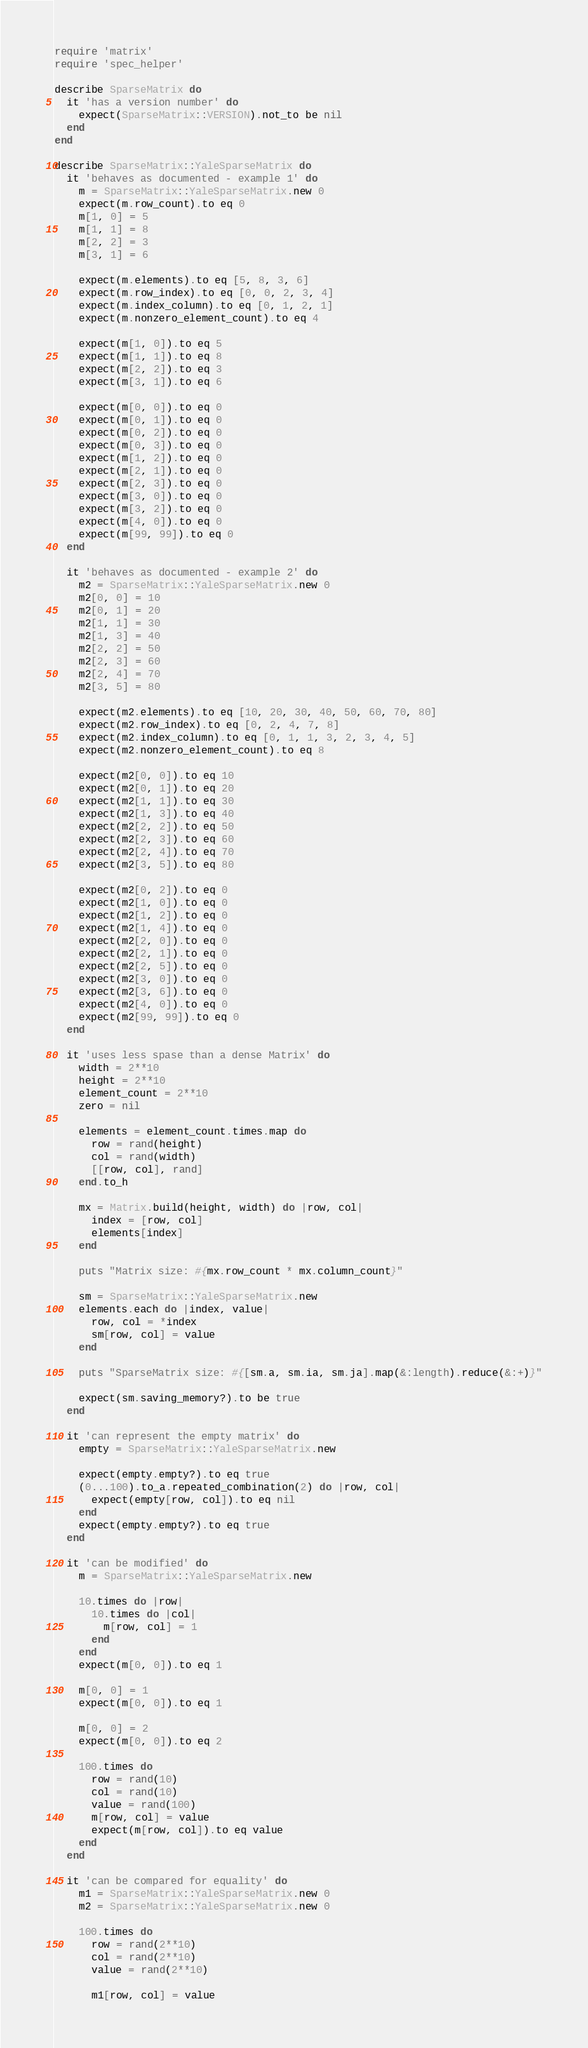Convert code to text. <code><loc_0><loc_0><loc_500><loc_500><_Ruby_>require 'matrix'
require 'spec_helper'

describe SparseMatrix do
  it 'has a version number' do
    expect(SparseMatrix::VERSION).not_to be nil
  end
end

describe SparseMatrix::YaleSparseMatrix do
  it 'behaves as documented - example 1' do
    m = SparseMatrix::YaleSparseMatrix.new 0
    expect(m.row_count).to eq 0
    m[1, 0] = 5
    m[1, 1] = 8
    m[2, 2] = 3
    m[3, 1] = 6

    expect(m.elements).to eq [5, 8, 3, 6]
    expect(m.row_index).to eq [0, 0, 2, 3, 4]
    expect(m.index_column).to eq [0, 1, 2, 1]
    expect(m.nonzero_element_count).to eq 4

    expect(m[1, 0]).to eq 5
    expect(m[1, 1]).to eq 8
    expect(m[2, 2]).to eq 3
    expect(m[3, 1]).to eq 6

    expect(m[0, 0]).to eq 0
    expect(m[0, 1]).to eq 0
    expect(m[0, 2]).to eq 0
    expect(m[0, 3]).to eq 0
    expect(m[1, 2]).to eq 0
    expect(m[2, 1]).to eq 0
    expect(m[2, 3]).to eq 0
    expect(m[3, 0]).to eq 0
    expect(m[3, 2]).to eq 0
    expect(m[4, 0]).to eq 0
    expect(m[99, 99]).to eq 0
  end

  it 'behaves as documented - example 2' do
    m2 = SparseMatrix::YaleSparseMatrix.new 0
    m2[0, 0] = 10
    m2[0, 1] = 20
    m2[1, 1] = 30
    m2[1, 3] = 40
    m2[2, 2] = 50
    m2[2, 3] = 60
    m2[2, 4] = 70
    m2[3, 5] = 80

    expect(m2.elements).to eq [10, 20, 30, 40, 50, 60, 70, 80]
    expect(m2.row_index).to eq [0, 2, 4, 7, 8]
    expect(m2.index_column).to eq [0, 1, 1, 3, 2, 3, 4, 5]
    expect(m2.nonzero_element_count).to eq 8

    expect(m2[0, 0]).to eq 10
    expect(m2[0, 1]).to eq 20
    expect(m2[1, 1]).to eq 30
    expect(m2[1, 3]).to eq 40
    expect(m2[2, 2]).to eq 50
    expect(m2[2, 3]).to eq 60
    expect(m2[2, 4]).to eq 70
    expect(m2[3, 5]).to eq 80

    expect(m2[0, 2]).to eq 0
    expect(m2[1, 0]).to eq 0
    expect(m2[1, 2]).to eq 0
    expect(m2[1, 4]).to eq 0
    expect(m2[2, 0]).to eq 0
    expect(m2[2, 1]).to eq 0
    expect(m2[2, 5]).to eq 0
    expect(m2[3, 0]).to eq 0
    expect(m2[3, 6]).to eq 0
    expect(m2[4, 0]).to eq 0
    expect(m2[99, 99]).to eq 0
  end

  it 'uses less spase than a dense Matrix' do
    width = 2**10
    height = 2**10
    element_count = 2**10
    zero = nil

    elements = element_count.times.map do
      row = rand(height)
      col = rand(width)
      [[row, col], rand]
    end.to_h

    mx = Matrix.build(height, width) do |row, col|
      index = [row, col]
      elements[index]
    end

    puts "Matrix size: #{mx.row_count * mx.column_count}"

    sm = SparseMatrix::YaleSparseMatrix.new
    elements.each do |index, value|
      row, col = *index
      sm[row, col] = value
    end

    puts "SparseMatrix size: #{[sm.a, sm.ia, sm.ja].map(&:length).reduce(&:+)}"

    expect(sm.saving_memory?).to be true
  end

  it 'can represent the empty matrix' do
    empty = SparseMatrix::YaleSparseMatrix.new

    expect(empty.empty?).to eq true
    (0...100).to_a.repeated_combination(2) do |row, col|
      expect(empty[row, col]).to eq nil
    end
    expect(empty.empty?).to eq true
  end

  it 'can be modified' do
    m = SparseMatrix::YaleSparseMatrix.new

    10.times do |row|
      10.times do |col|
        m[row, col] = 1
      end
    end
    expect(m[0, 0]).to eq 1

    m[0, 0] = 1
    expect(m[0, 0]).to eq 1

    m[0, 0] = 2
    expect(m[0, 0]).to eq 2

    100.times do
      row = rand(10)
      col = rand(10)
      value = rand(100)
      m[row, col] = value
      expect(m[row, col]).to eq value
    end
  end

  it 'can be compared for equality' do
    m1 = SparseMatrix::YaleSparseMatrix.new 0
    m2 = SparseMatrix::YaleSparseMatrix.new 0

    100.times do
      row = rand(2**10)
      col = rand(2**10)
      value = rand(2**10)

      m1[row, col] = value</code> 